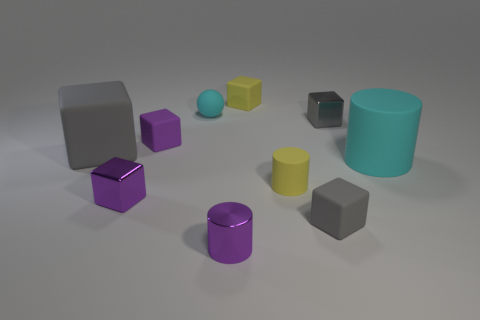Subtract all gray cubes. How many were subtracted if there are1gray cubes left? 2 Subtract all brown balls. How many gray blocks are left? 3 Subtract all yellow cubes. How many cubes are left? 5 Subtract all metal blocks. How many blocks are left? 4 Subtract 1 cubes. How many cubes are left? 5 Subtract all red cubes. Subtract all cyan cylinders. How many cubes are left? 6 Subtract all cubes. How many objects are left? 4 Add 8 tiny purple metallic blocks. How many tiny purple metallic blocks are left? 9 Add 6 large green metallic cubes. How many large green metallic cubes exist? 6 Subtract 0 brown blocks. How many objects are left? 10 